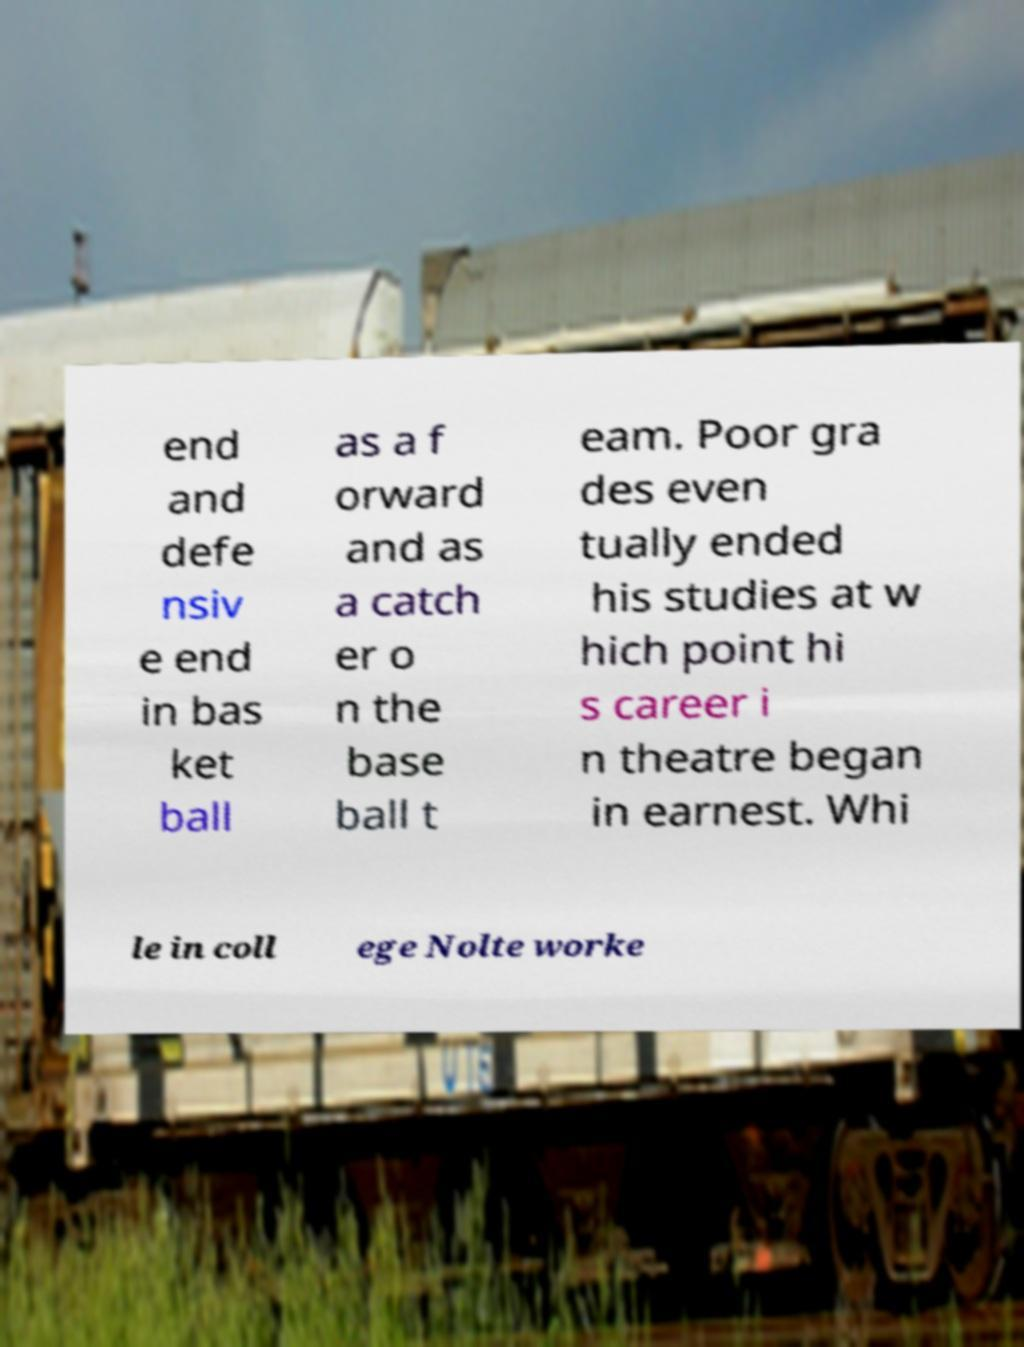For documentation purposes, I need the text within this image transcribed. Could you provide that? end and defe nsiv e end in bas ket ball as a f orward and as a catch er o n the base ball t eam. Poor gra des even tually ended his studies at w hich point hi s career i n theatre began in earnest. Whi le in coll ege Nolte worke 